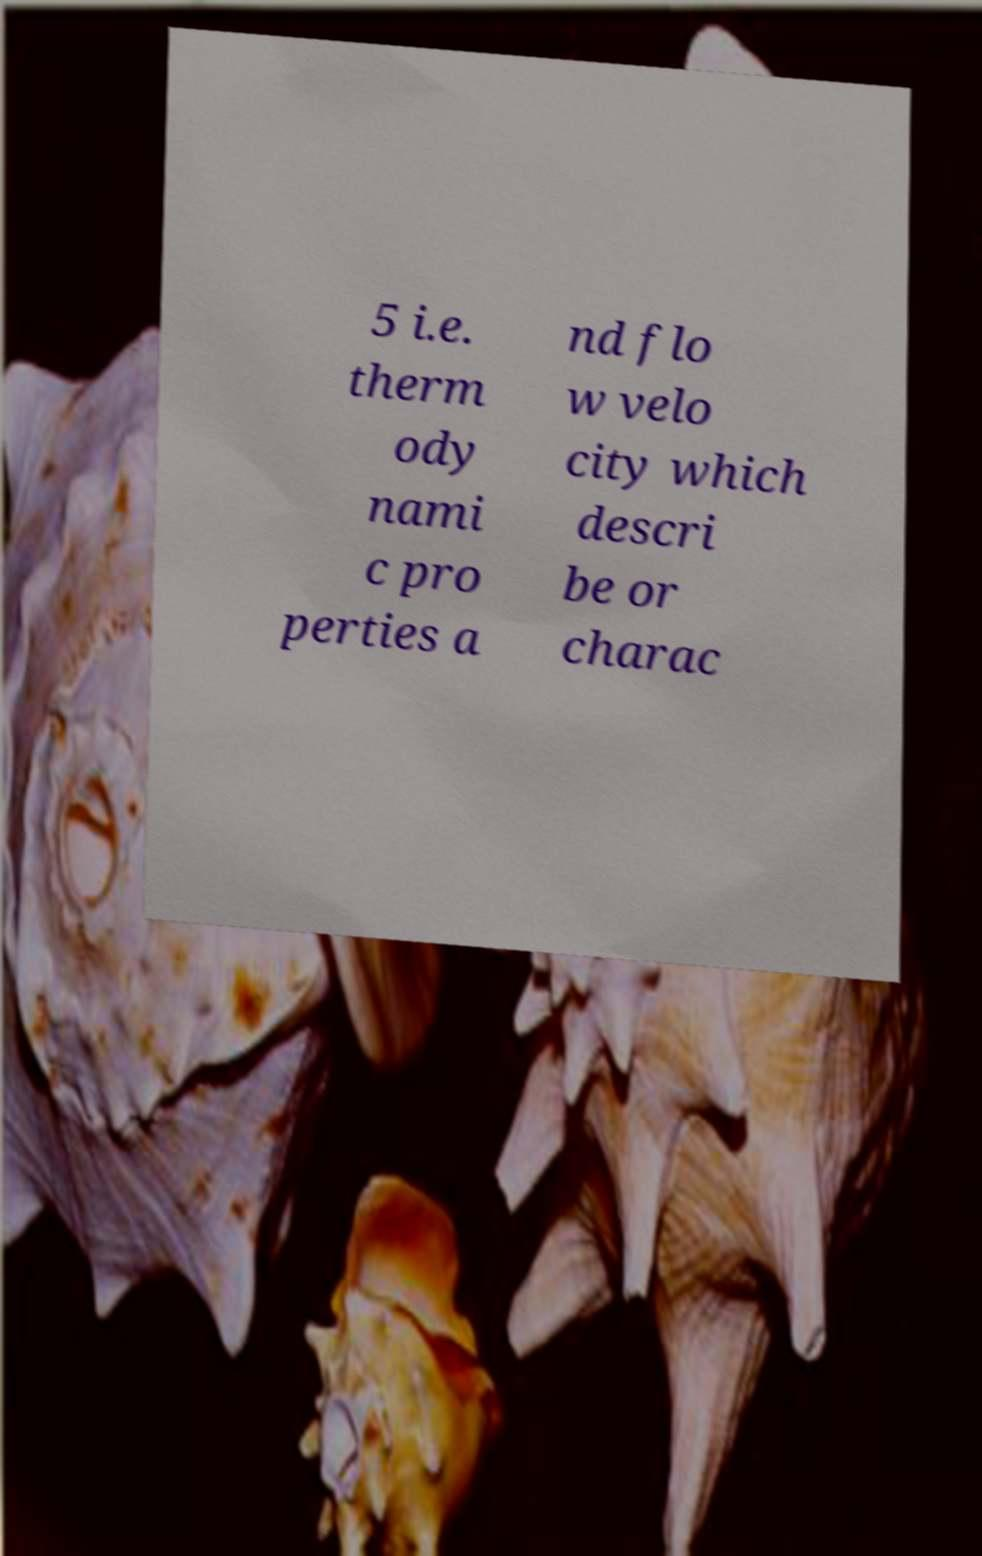For documentation purposes, I need the text within this image transcribed. Could you provide that? 5 i.e. therm ody nami c pro perties a nd flo w velo city which descri be or charac 